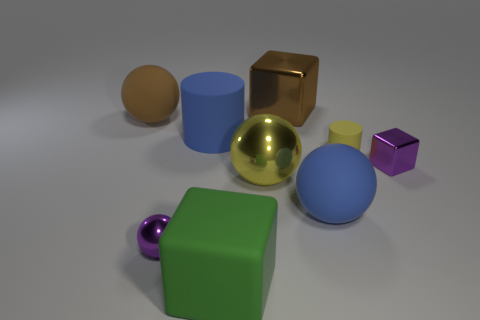Add 1 big brown shiny blocks. How many objects exist? 10 Subtract all cylinders. How many objects are left? 7 Subtract 0 gray spheres. How many objects are left? 9 Subtract all green matte blocks. Subtract all metal things. How many objects are left? 4 Add 7 blue things. How many blue things are left? 9 Add 2 purple shiny things. How many purple shiny things exist? 4 